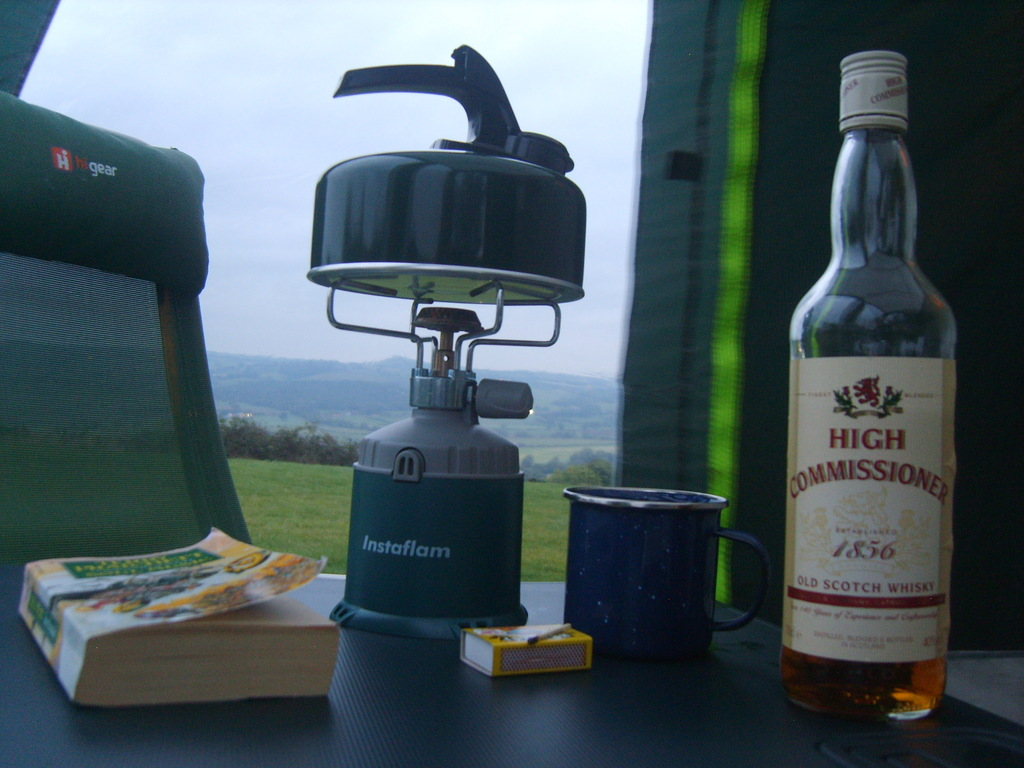What items are shown in the image, and how do they contribute to the theme of camping? The image displays a tea kettle on an Instaflam burner, suggesting preparation for a warm drink, a bottle of High Commissioner scotch whisky for evening enjoyment, and a novel for leisure reading, all of which enhance the camping experience by providing comfort and entertainment amidst a natural setting. 